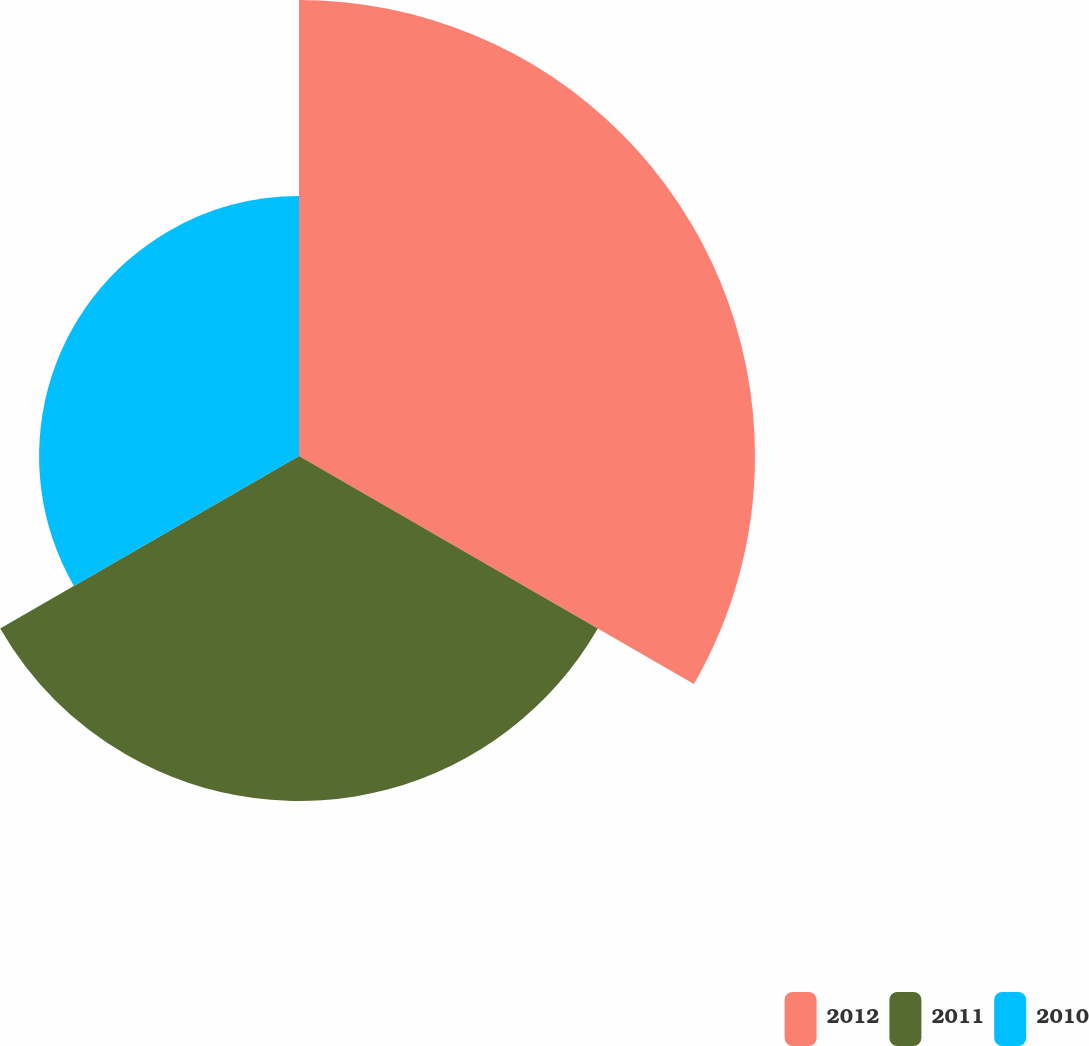Convert chart. <chart><loc_0><loc_0><loc_500><loc_500><pie_chart><fcel>2012<fcel>2011<fcel>2010<nl><fcel>42.98%<fcel>32.52%<fcel>24.5%<nl></chart> 